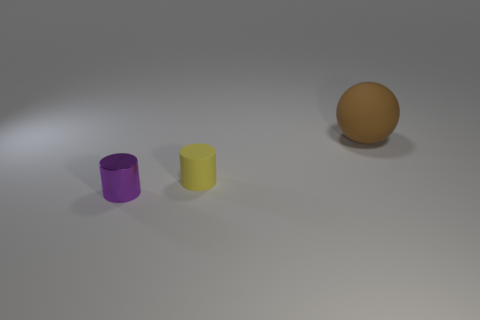How is the lighting condition in the scene? The lighting is moderately bright, likely diffused, as there are soft shadows cast underneath and to the right of the objects, indicating the light source is coming from the left side. 